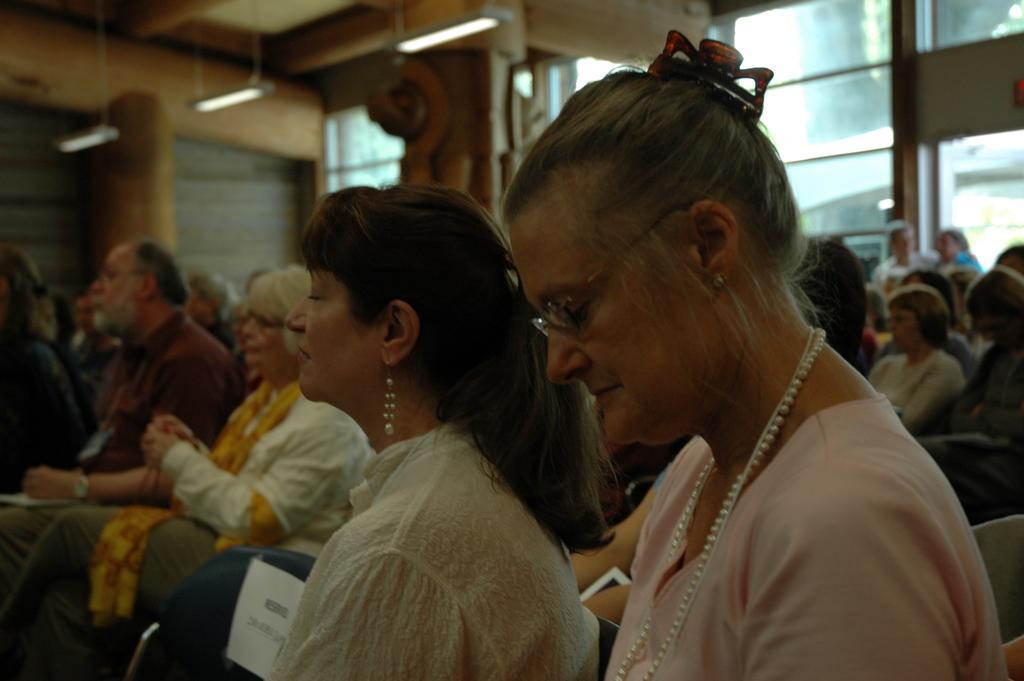Could you give a brief overview of what you see in this image? In this image I can see people sitting on chairs. In the background I can see framed glass wall, lights and some other objects. 